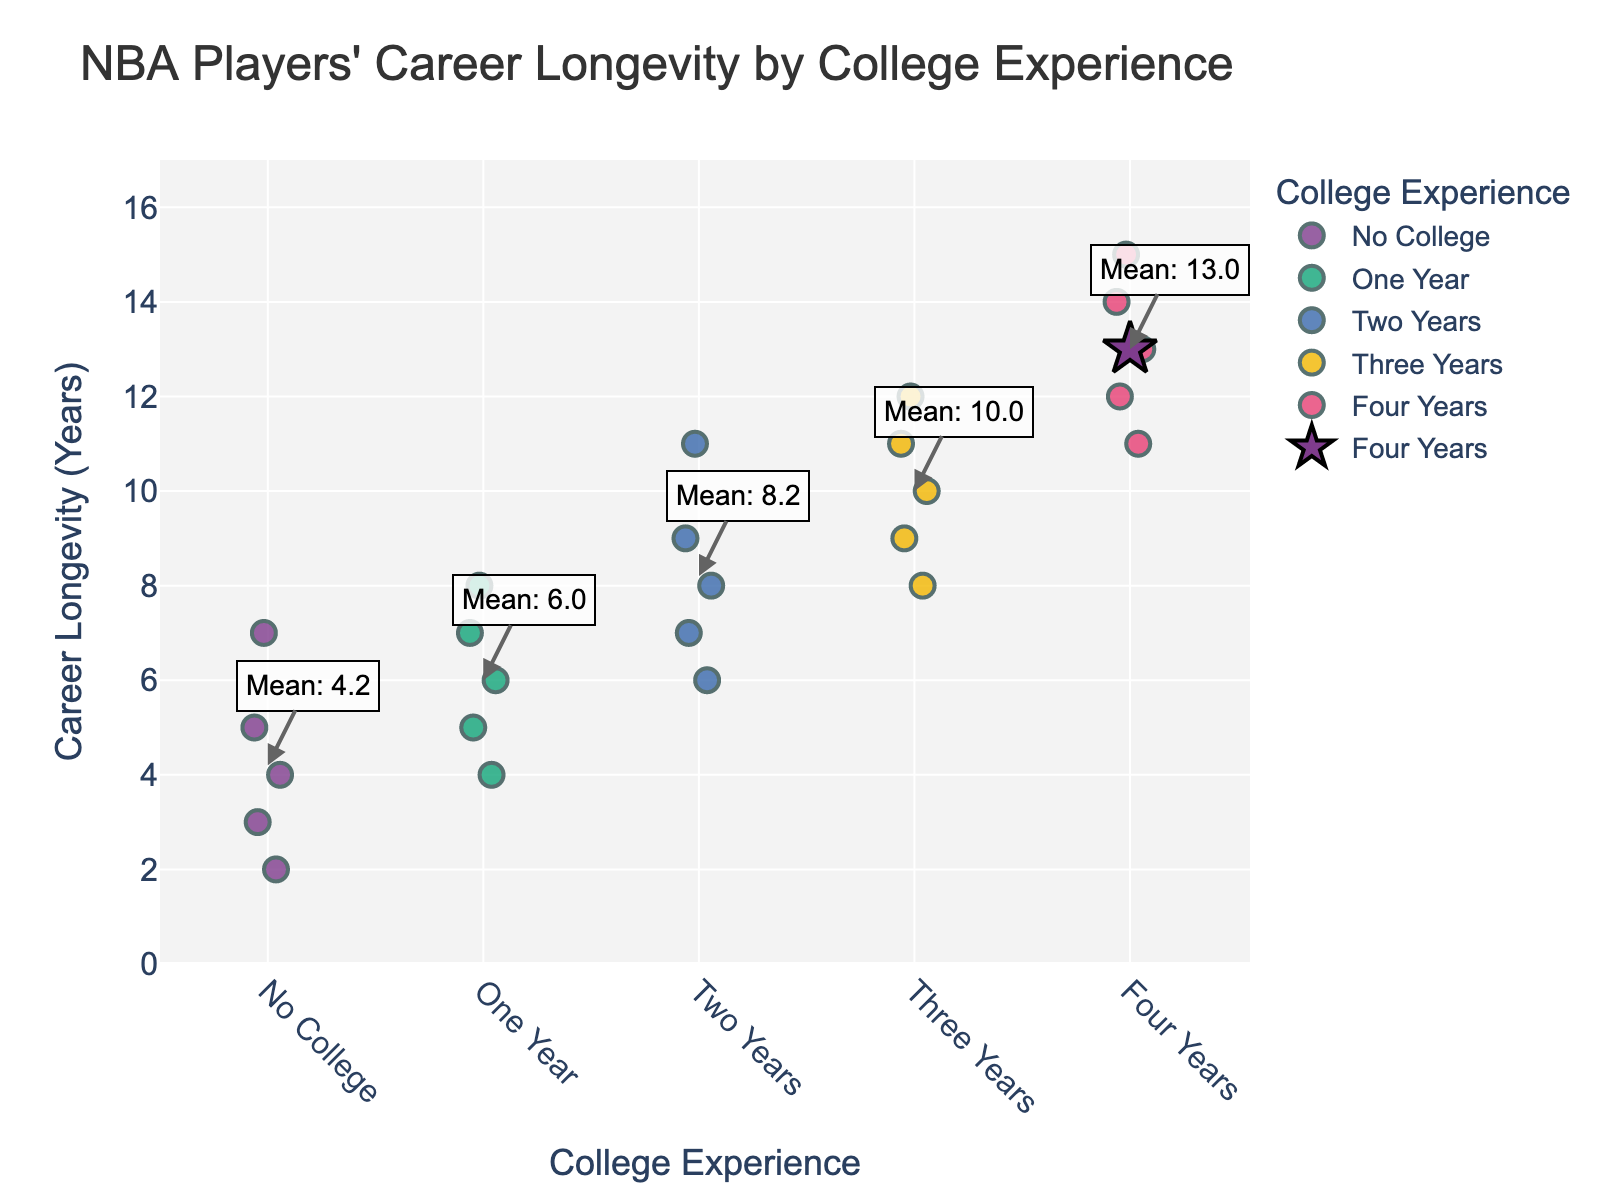How many different categories are displayed on the x-axis? The x-axis displays different levels of college experience: "No College", "One Year", "Two Years", "Three Years", and "Four Years". Each level is a unique category.
Answer: 5 What is the highest career longevity among players with two years of college experience? By looking at the data points for "Two Years" on the x-axis, the highest career longevity indicated is 11 years.
Answer: 11 years Which group of players has the highest mean career longevity? The figure shows mean values indicated by stars. The mean for each group is also annotated. The "Four Years" group has the highest mean career longevity of around 13 years.
Answer: Four Years What is the range of career longevity for players with three years of college experience? The data points for "Three Years" on the x-axis show the lowest value of 8 and the highest value of 12. The range is calculated as 12 - 8 = 4 years.
Answer: 4 years Comparing players with no college experience and those with one year, which group has a higher median career longevity? By analyzing the spread and middle values of the data points in both groups, the "One Year" group shows a higher median value as the middle point appears to be around 6 years, while for "No College" it is around 4 years.
Answer: One Year What is the average career longevity for players who went to college for two years? From the annotated figures, the mean for "Two Years" is approximately 8.2 years. (Sum of all points: (9+7+11+6+8)/5 = 41/5 = 8.2)
Answer: 8.2 years Are there any outliers in the career longevity data for players with four years of college experience? Observing the data points for "Four Years," there are no points that appear significantly distant from the others. All values are relatively close within the 11-15 range.
Answer: No How does career longevity for players without college compare to those with four years of college? Players with "No College" experience generally show lower career longevity centered around a range of 2 to 7 years, whereas players with "Four Years" show a higher longevity range of 11 to 15 years and a higher mean.
Answer: Four Years has higher longevity What is the mean career longevity for players with one year of college experience? The star markers on the plot represent mean values. For "One Year" of college, the annotated mean value is approximately 6 years. (Sum of all points: (6+8+4+7+5)/5 = 30/5 = 6)
Answer: 6 years 